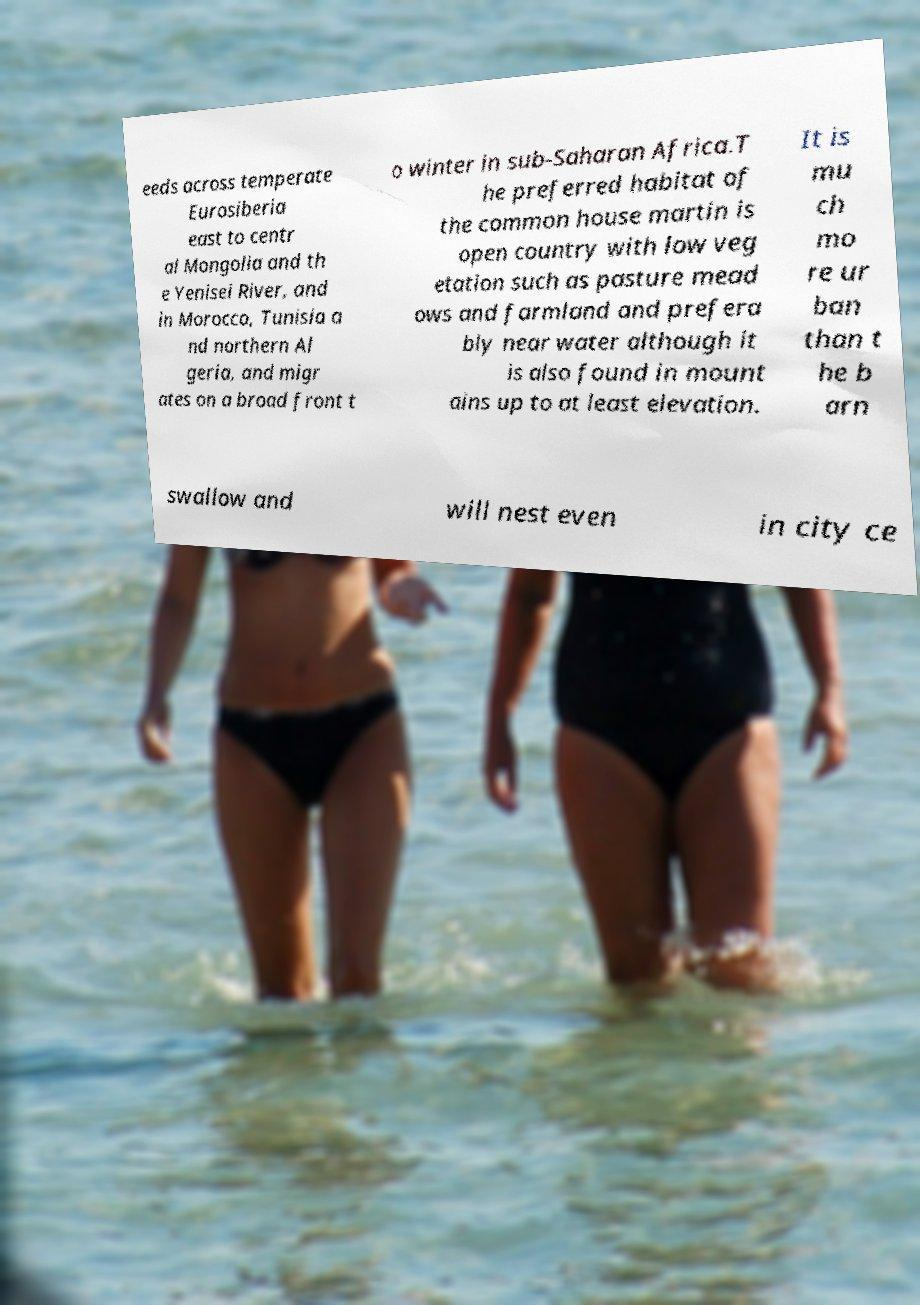Please identify and transcribe the text found in this image. eeds across temperate Eurosiberia east to centr al Mongolia and th e Yenisei River, and in Morocco, Tunisia a nd northern Al geria, and migr ates on a broad front t o winter in sub-Saharan Africa.T he preferred habitat of the common house martin is open country with low veg etation such as pasture mead ows and farmland and prefera bly near water although it is also found in mount ains up to at least elevation. It is mu ch mo re ur ban than t he b arn swallow and will nest even in city ce 